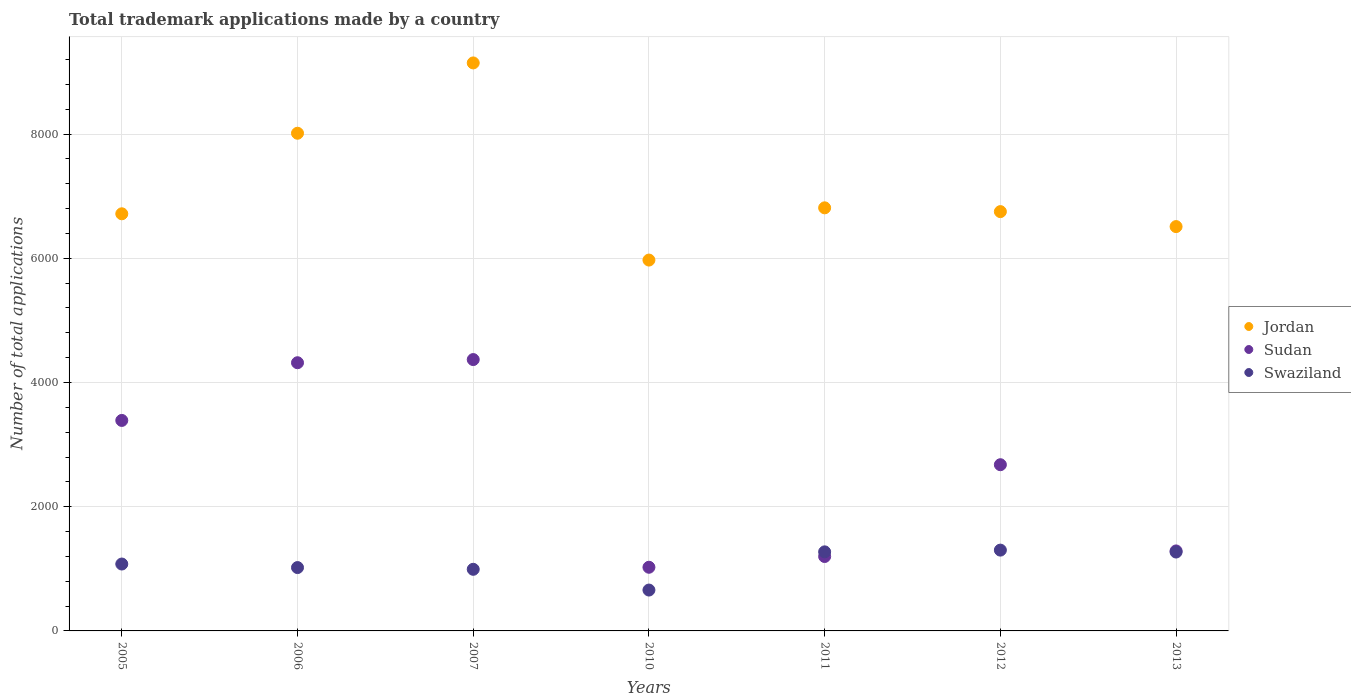Is the number of dotlines equal to the number of legend labels?
Provide a short and direct response. Yes. What is the number of applications made by in Jordan in 2013?
Your answer should be compact. 6510. Across all years, what is the maximum number of applications made by in Swaziland?
Your answer should be very brief. 1301. Across all years, what is the minimum number of applications made by in Swaziland?
Offer a very short reply. 658. What is the total number of applications made by in Jordan in the graph?
Your answer should be compact. 4.99e+04. What is the difference between the number of applications made by in Jordan in 2006 and that in 2010?
Make the answer very short. 2042. What is the difference between the number of applications made by in Sudan in 2006 and the number of applications made by in Jordan in 2012?
Your answer should be compact. -2433. What is the average number of applications made by in Sudan per year?
Offer a very short reply. 2609. In the year 2007, what is the difference between the number of applications made by in Jordan and number of applications made by in Swaziland?
Provide a short and direct response. 8153. In how many years, is the number of applications made by in Sudan greater than 5600?
Your answer should be compact. 0. What is the ratio of the number of applications made by in Jordan in 2011 to that in 2013?
Make the answer very short. 1.05. Is the difference between the number of applications made by in Jordan in 2010 and 2012 greater than the difference between the number of applications made by in Swaziland in 2010 and 2012?
Offer a very short reply. No. What is the difference between the highest and the second highest number of applications made by in Jordan?
Your response must be concise. 1132. What is the difference between the highest and the lowest number of applications made by in Sudan?
Give a very brief answer. 3344. In how many years, is the number of applications made by in Swaziland greater than the average number of applications made by in Swaziland taken over all years?
Your response must be concise. 3. Is the sum of the number of applications made by in Jordan in 2010 and 2012 greater than the maximum number of applications made by in Sudan across all years?
Give a very brief answer. Yes. Is it the case that in every year, the sum of the number of applications made by in Sudan and number of applications made by in Jordan  is greater than the number of applications made by in Swaziland?
Offer a terse response. Yes. Does the number of applications made by in Sudan monotonically increase over the years?
Your response must be concise. No. Is the number of applications made by in Swaziland strictly greater than the number of applications made by in Jordan over the years?
Provide a succinct answer. No. Is the number of applications made by in Jordan strictly less than the number of applications made by in Sudan over the years?
Your response must be concise. No. How many dotlines are there?
Provide a short and direct response. 3. How many years are there in the graph?
Your response must be concise. 7. Does the graph contain grids?
Your answer should be compact. Yes. Where does the legend appear in the graph?
Keep it short and to the point. Center right. How many legend labels are there?
Give a very brief answer. 3. How are the legend labels stacked?
Your answer should be compact. Vertical. What is the title of the graph?
Offer a very short reply. Total trademark applications made by a country. Does "Sudan" appear as one of the legend labels in the graph?
Keep it short and to the point. Yes. What is the label or title of the Y-axis?
Offer a terse response. Number of total applications. What is the Number of total applications of Jordan in 2005?
Your response must be concise. 6716. What is the Number of total applications in Sudan in 2005?
Make the answer very short. 3389. What is the Number of total applications in Swaziland in 2005?
Provide a short and direct response. 1077. What is the Number of total applications in Jordan in 2006?
Offer a very short reply. 8013. What is the Number of total applications of Sudan in 2006?
Keep it short and to the point. 4318. What is the Number of total applications of Swaziland in 2006?
Your response must be concise. 1020. What is the Number of total applications in Jordan in 2007?
Your answer should be very brief. 9145. What is the Number of total applications of Sudan in 2007?
Offer a terse response. 4369. What is the Number of total applications of Swaziland in 2007?
Your answer should be compact. 992. What is the Number of total applications of Jordan in 2010?
Provide a short and direct response. 5971. What is the Number of total applications of Sudan in 2010?
Make the answer very short. 1025. What is the Number of total applications of Swaziland in 2010?
Make the answer very short. 658. What is the Number of total applications in Jordan in 2011?
Keep it short and to the point. 6812. What is the Number of total applications of Sudan in 2011?
Your answer should be very brief. 1198. What is the Number of total applications of Swaziland in 2011?
Give a very brief answer. 1273. What is the Number of total applications in Jordan in 2012?
Offer a very short reply. 6751. What is the Number of total applications of Sudan in 2012?
Your response must be concise. 2676. What is the Number of total applications of Swaziland in 2012?
Your answer should be very brief. 1301. What is the Number of total applications of Jordan in 2013?
Ensure brevity in your answer.  6510. What is the Number of total applications of Sudan in 2013?
Make the answer very short. 1288. What is the Number of total applications in Swaziland in 2013?
Make the answer very short. 1270. Across all years, what is the maximum Number of total applications in Jordan?
Make the answer very short. 9145. Across all years, what is the maximum Number of total applications in Sudan?
Offer a terse response. 4369. Across all years, what is the maximum Number of total applications of Swaziland?
Provide a short and direct response. 1301. Across all years, what is the minimum Number of total applications in Jordan?
Your answer should be very brief. 5971. Across all years, what is the minimum Number of total applications in Sudan?
Your answer should be compact. 1025. Across all years, what is the minimum Number of total applications in Swaziland?
Provide a short and direct response. 658. What is the total Number of total applications in Jordan in the graph?
Ensure brevity in your answer.  4.99e+04. What is the total Number of total applications of Sudan in the graph?
Your answer should be very brief. 1.83e+04. What is the total Number of total applications in Swaziland in the graph?
Keep it short and to the point. 7591. What is the difference between the Number of total applications of Jordan in 2005 and that in 2006?
Provide a short and direct response. -1297. What is the difference between the Number of total applications in Sudan in 2005 and that in 2006?
Your response must be concise. -929. What is the difference between the Number of total applications of Swaziland in 2005 and that in 2006?
Ensure brevity in your answer.  57. What is the difference between the Number of total applications in Jordan in 2005 and that in 2007?
Your answer should be very brief. -2429. What is the difference between the Number of total applications in Sudan in 2005 and that in 2007?
Make the answer very short. -980. What is the difference between the Number of total applications in Jordan in 2005 and that in 2010?
Ensure brevity in your answer.  745. What is the difference between the Number of total applications of Sudan in 2005 and that in 2010?
Ensure brevity in your answer.  2364. What is the difference between the Number of total applications in Swaziland in 2005 and that in 2010?
Make the answer very short. 419. What is the difference between the Number of total applications of Jordan in 2005 and that in 2011?
Keep it short and to the point. -96. What is the difference between the Number of total applications in Sudan in 2005 and that in 2011?
Give a very brief answer. 2191. What is the difference between the Number of total applications in Swaziland in 2005 and that in 2011?
Make the answer very short. -196. What is the difference between the Number of total applications of Jordan in 2005 and that in 2012?
Your response must be concise. -35. What is the difference between the Number of total applications in Sudan in 2005 and that in 2012?
Make the answer very short. 713. What is the difference between the Number of total applications of Swaziland in 2005 and that in 2012?
Provide a succinct answer. -224. What is the difference between the Number of total applications in Jordan in 2005 and that in 2013?
Provide a short and direct response. 206. What is the difference between the Number of total applications of Sudan in 2005 and that in 2013?
Offer a terse response. 2101. What is the difference between the Number of total applications in Swaziland in 2005 and that in 2013?
Make the answer very short. -193. What is the difference between the Number of total applications of Jordan in 2006 and that in 2007?
Make the answer very short. -1132. What is the difference between the Number of total applications in Sudan in 2006 and that in 2007?
Give a very brief answer. -51. What is the difference between the Number of total applications of Jordan in 2006 and that in 2010?
Provide a succinct answer. 2042. What is the difference between the Number of total applications in Sudan in 2006 and that in 2010?
Your answer should be compact. 3293. What is the difference between the Number of total applications of Swaziland in 2006 and that in 2010?
Give a very brief answer. 362. What is the difference between the Number of total applications in Jordan in 2006 and that in 2011?
Offer a terse response. 1201. What is the difference between the Number of total applications of Sudan in 2006 and that in 2011?
Give a very brief answer. 3120. What is the difference between the Number of total applications of Swaziland in 2006 and that in 2011?
Keep it short and to the point. -253. What is the difference between the Number of total applications in Jordan in 2006 and that in 2012?
Provide a succinct answer. 1262. What is the difference between the Number of total applications in Sudan in 2006 and that in 2012?
Give a very brief answer. 1642. What is the difference between the Number of total applications of Swaziland in 2006 and that in 2012?
Make the answer very short. -281. What is the difference between the Number of total applications in Jordan in 2006 and that in 2013?
Your response must be concise. 1503. What is the difference between the Number of total applications of Sudan in 2006 and that in 2013?
Your response must be concise. 3030. What is the difference between the Number of total applications of Swaziland in 2006 and that in 2013?
Your response must be concise. -250. What is the difference between the Number of total applications in Jordan in 2007 and that in 2010?
Keep it short and to the point. 3174. What is the difference between the Number of total applications in Sudan in 2007 and that in 2010?
Give a very brief answer. 3344. What is the difference between the Number of total applications of Swaziland in 2007 and that in 2010?
Give a very brief answer. 334. What is the difference between the Number of total applications of Jordan in 2007 and that in 2011?
Your answer should be compact. 2333. What is the difference between the Number of total applications in Sudan in 2007 and that in 2011?
Your response must be concise. 3171. What is the difference between the Number of total applications in Swaziland in 2007 and that in 2011?
Your answer should be compact. -281. What is the difference between the Number of total applications in Jordan in 2007 and that in 2012?
Keep it short and to the point. 2394. What is the difference between the Number of total applications of Sudan in 2007 and that in 2012?
Provide a succinct answer. 1693. What is the difference between the Number of total applications of Swaziland in 2007 and that in 2012?
Offer a terse response. -309. What is the difference between the Number of total applications in Jordan in 2007 and that in 2013?
Ensure brevity in your answer.  2635. What is the difference between the Number of total applications in Sudan in 2007 and that in 2013?
Offer a terse response. 3081. What is the difference between the Number of total applications in Swaziland in 2007 and that in 2013?
Offer a terse response. -278. What is the difference between the Number of total applications of Jordan in 2010 and that in 2011?
Your response must be concise. -841. What is the difference between the Number of total applications of Sudan in 2010 and that in 2011?
Offer a very short reply. -173. What is the difference between the Number of total applications in Swaziland in 2010 and that in 2011?
Ensure brevity in your answer.  -615. What is the difference between the Number of total applications in Jordan in 2010 and that in 2012?
Your answer should be compact. -780. What is the difference between the Number of total applications in Sudan in 2010 and that in 2012?
Provide a short and direct response. -1651. What is the difference between the Number of total applications in Swaziland in 2010 and that in 2012?
Offer a very short reply. -643. What is the difference between the Number of total applications in Jordan in 2010 and that in 2013?
Offer a terse response. -539. What is the difference between the Number of total applications in Sudan in 2010 and that in 2013?
Provide a succinct answer. -263. What is the difference between the Number of total applications of Swaziland in 2010 and that in 2013?
Ensure brevity in your answer.  -612. What is the difference between the Number of total applications of Sudan in 2011 and that in 2012?
Provide a succinct answer. -1478. What is the difference between the Number of total applications of Swaziland in 2011 and that in 2012?
Give a very brief answer. -28. What is the difference between the Number of total applications in Jordan in 2011 and that in 2013?
Offer a terse response. 302. What is the difference between the Number of total applications of Sudan in 2011 and that in 2013?
Offer a terse response. -90. What is the difference between the Number of total applications in Swaziland in 2011 and that in 2013?
Your answer should be very brief. 3. What is the difference between the Number of total applications in Jordan in 2012 and that in 2013?
Offer a terse response. 241. What is the difference between the Number of total applications of Sudan in 2012 and that in 2013?
Give a very brief answer. 1388. What is the difference between the Number of total applications of Jordan in 2005 and the Number of total applications of Sudan in 2006?
Offer a terse response. 2398. What is the difference between the Number of total applications of Jordan in 2005 and the Number of total applications of Swaziland in 2006?
Offer a terse response. 5696. What is the difference between the Number of total applications in Sudan in 2005 and the Number of total applications in Swaziland in 2006?
Keep it short and to the point. 2369. What is the difference between the Number of total applications in Jordan in 2005 and the Number of total applications in Sudan in 2007?
Make the answer very short. 2347. What is the difference between the Number of total applications in Jordan in 2005 and the Number of total applications in Swaziland in 2007?
Your answer should be very brief. 5724. What is the difference between the Number of total applications of Sudan in 2005 and the Number of total applications of Swaziland in 2007?
Offer a very short reply. 2397. What is the difference between the Number of total applications in Jordan in 2005 and the Number of total applications in Sudan in 2010?
Your response must be concise. 5691. What is the difference between the Number of total applications in Jordan in 2005 and the Number of total applications in Swaziland in 2010?
Make the answer very short. 6058. What is the difference between the Number of total applications in Sudan in 2005 and the Number of total applications in Swaziland in 2010?
Keep it short and to the point. 2731. What is the difference between the Number of total applications in Jordan in 2005 and the Number of total applications in Sudan in 2011?
Keep it short and to the point. 5518. What is the difference between the Number of total applications of Jordan in 2005 and the Number of total applications of Swaziland in 2011?
Offer a very short reply. 5443. What is the difference between the Number of total applications of Sudan in 2005 and the Number of total applications of Swaziland in 2011?
Offer a terse response. 2116. What is the difference between the Number of total applications in Jordan in 2005 and the Number of total applications in Sudan in 2012?
Offer a very short reply. 4040. What is the difference between the Number of total applications of Jordan in 2005 and the Number of total applications of Swaziland in 2012?
Provide a short and direct response. 5415. What is the difference between the Number of total applications of Sudan in 2005 and the Number of total applications of Swaziland in 2012?
Provide a short and direct response. 2088. What is the difference between the Number of total applications of Jordan in 2005 and the Number of total applications of Sudan in 2013?
Provide a succinct answer. 5428. What is the difference between the Number of total applications in Jordan in 2005 and the Number of total applications in Swaziland in 2013?
Your response must be concise. 5446. What is the difference between the Number of total applications in Sudan in 2005 and the Number of total applications in Swaziland in 2013?
Ensure brevity in your answer.  2119. What is the difference between the Number of total applications in Jordan in 2006 and the Number of total applications in Sudan in 2007?
Keep it short and to the point. 3644. What is the difference between the Number of total applications in Jordan in 2006 and the Number of total applications in Swaziland in 2007?
Make the answer very short. 7021. What is the difference between the Number of total applications of Sudan in 2006 and the Number of total applications of Swaziland in 2007?
Your response must be concise. 3326. What is the difference between the Number of total applications of Jordan in 2006 and the Number of total applications of Sudan in 2010?
Make the answer very short. 6988. What is the difference between the Number of total applications in Jordan in 2006 and the Number of total applications in Swaziland in 2010?
Ensure brevity in your answer.  7355. What is the difference between the Number of total applications of Sudan in 2006 and the Number of total applications of Swaziland in 2010?
Offer a very short reply. 3660. What is the difference between the Number of total applications in Jordan in 2006 and the Number of total applications in Sudan in 2011?
Your answer should be very brief. 6815. What is the difference between the Number of total applications in Jordan in 2006 and the Number of total applications in Swaziland in 2011?
Provide a succinct answer. 6740. What is the difference between the Number of total applications in Sudan in 2006 and the Number of total applications in Swaziland in 2011?
Your response must be concise. 3045. What is the difference between the Number of total applications in Jordan in 2006 and the Number of total applications in Sudan in 2012?
Provide a succinct answer. 5337. What is the difference between the Number of total applications of Jordan in 2006 and the Number of total applications of Swaziland in 2012?
Ensure brevity in your answer.  6712. What is the difference between the Number of total applications in Sudan in 2006 and the Number of total applications in Swaziland in 2012?
Provide a short and direct response. 3017. What is the difference between the Number of total applications of Jordan in 2006 and the Number of total applications of Sudan in 2013?
Ensure brevity in your answer.  6725. What is the difference between the Number of total applications of Jordan in 2006 and the Number of total applications of Swaziland in 2013?
Make the answer very short. 6743. What is the difference between the Number of total applications in Sudan in 2006 and the Number of total applications in Swaziland in 2013?
Offer a terse response. 3048. What is the difference between the Number of total applications of Jordan in 2007 and the Number of total applications of Sudan in 2010?
Give a very brief answer. 8120. What is the difference between the Number of total applications of Jordan in 2007 and the Number of total applications of Swaziland in 2010?
Give a very brief answer. 8487. What is the difference between the Number of total applications in Sudan in 2007 and the Number of total applications in Swaziland in 2010?
Provide a short and direct response. 3711. What is the difference between the Number of total applications in Jordan in 2007 and the Number of total applications in Sudan in 2011?
Make the answer very short. 7947. What is the difference between the Number of total applications in Jordan in 2007 and the Number of total applications in Swaziland in 2011?
Offer a terse response. 7872. What is the difference between the Number of total applications of Sudan in 2007 and the Number of total applications of Swaziland in 2011?
Give a very brief answer. 3096. What is the difference between the Number of total applications in Jordan in 2007 and the Number of total applications in Sudan in 2012?
Your answer should be very brief. 6469. What is the difference between the Number of total applications of Jordan in 2007 and the Number of total applications of Swaziland in 2012?
Offer a terse response. 7844. What is the difference between the Number of total applications of Sudan in 2007 and the Number of total applications of Swaziland in 2012?
Offer a very short reply. 3068. What is the difference between the Number of total applications in Jordan in 2007 and the Number of total applications in Sudan in 2013?
Your answer should be compact. 7857. What is the difference between the Number of total applications in Jordan in 2007 and the Number of total applications in Swaziland in 2013?
Ensure brevity in your answer.  7875. What is the difference between the Number of total applications in Sudan in 2007 and the Number of total applications in Swaziland in 2013?
Give a very brief answer. 3099. What is the difference between the Number of total applications in Jordan in 2010 and the Number of total applications in Sudan in 2011?
Give a very brief answer. 4773. What is the difference between the Number of total applications in Jordan in 2010 and the Number of total applications in Swaziland in 2011?
Keep it short and to the point. 4698. What is the difference between the Number of total applications of Sudan in 2010 and the Number of total applications of Swaziland in 2011?
Provide a succinct answer. -248. What is the difference between the Number of total applications of Jordan in 2010 and the Number of total applications of Sudan in 2012?
Your answer should be compact. 3295. What is the difference between the Number of total applications of Jordan in 2010 and the Number of total applications of Swaziland in 2012?
Give a very brief answer. 4670. What is the difference between the Number of total applications in Sudan in 2010 and the Number of total applications in Swaziland in 2012?
Ensure brevity in your answer.  -276. What is the difference between the Number of total applications in Jordan in 2010 and the Number of total applications in Sudan in 2013?
Provide a short and direct response. 4683. What is the difference between the Number of total applications in Jordan in 2010 and the Number of total applications in Swaziland in 2013?
Your response must be concise. 4701. What is the difference between the Number of total applications in Sudan in 2010 and the Number of total applications in Swaziland in 2013?
Your answer should be compact. -245. What is the difference between the Number of total applications of Jordan in 2011 and the Number of total applications of Sudan in 2012?
Your answer should be compact. 4136. What is the difference between the Number of total applications in Jordan in 2011 and the Number of total applications in Swaziland in 2012?
Provide a succinct answer. 5511. What is the difference between the Number of total applications in Sudan in 2011 and the Number of total applications in Swaziland in 2012?
Offer a terse response. -103. What is the difference between the Number of total applications in Jordan in 2011 and the Number of total applications in Sudan in 2013?
Ensure brevity in your answer.  5524. What is the difference between the Number of total applications of Jordan in 2011 and the Number of total applications of Swaziland in 2013?
Keep it short and to the point. 5542. What is the difference between the Number of total applications in Sudan in 2011 and the Number of total applications in Swaziland in 2013?
Provide a succinct answer. -72. What is the difference between the Number of total applications of Jordan in 2012 and the Number of total applications of Sudan in 2013?
Your answer should be compact. 5463. What is the difference between the Number of total applications of Jordan in 2012 and the Number of total applications of Swaziland in 2013?
Provide a short and direct response. 5481. What is the difference between the Number of total applications in Sudan in 2012 and the Number of total applications in Swaziland in 2013?
Make the answer very short. 1406. What is the average Number of total applications of Jordan per year?
Provide a short and direct response. 7131.14. What is the average Number of total applications in Sudan per year?
Your response must be concise. 2609. What is the average Number of total applications of Swaziland per year?
Offer a very short reply. 1084.43. In the year 2005, what is the difference between the Number of total applications of Jordan and Number of total applications of Sudan?
Offer a terse response. 3327. In the year 2005, what is the difference between the Number of total applications of Jordan and Number of total applications of Swaziland?
Make the answer very short. 5639. In the year 2005, what is the difference between the Number of total applications in Sudan and Number of total applications in Swaziland?
Provide a succinct answer. 2312. In the year 2006, what is the difference between the Number of total applications of Jordan and Number of total applications of Sudan?
Keep it short and to the point. 3695. In the year 2006, what is the difference between the Number of total applications of Jordan and Number of total applications of Swaziland?
Provide a short and direct response. 6993. In the year 2006, what is the difference between the Number of total applications of Sudan and Number of total applications of Swaziland?
Provide a short and direct response. 3298. In the year 2007, what is the difference between the Number of total applications of Jordan and Number of total applications of Sudan?
Your response must be concise. 4776. In the year 2007, what is the difference between the Number of total applications of Jordan and Number of total applications of Swaziland?
Provide a succinct answer. 8153. In the year 2007, what is the difference between the Number of total applications of Sudan and Number of total applications of Swaziland?
Keep it short and to the point. 3377. In the year 2010, what is the difference between the Number of total applications of Jordan and Number of total applications of Sudan?
Your answer should be compact. 4946. In the year 2010, what is the difference between the Number of total applications of Jordan and Number of total applications of Swaziland?
Keep it short and to the point. 5313. In the year 2010, what is the difference between the Number of total applications of Sudan and Number of total applications of Swaziland?
Provide a short and direct response. 367. In the year 2011, what is the difference between the Number of total applications of Jordan and Number of total applications of Sudan?
Offer a very short reply. 5614. In the year 2011, what is the difference between the Number of total applications in Jordan and Number of total applications in Swaziland?
Provide a succinct answer. 5539. In the year 2011, what is the difference between the Number of total applications of Sudan and Number of total applications of Swaziland?
Provide a short and direct response. -75. In the year 2012, what is the difference between the Number of total applications of Jordan and Number of total applications of Sudan?
Give a very brief answer. 4075. In the year 2012, what is the difference between the Number of total applications in Jordan and Number of total applications in Swaziland?
Ensure brevity in your answer.  5450. In the year 2012, what is the difference between the Number of total applications in Sudan and Number of total applications in Swaziland?
Ensure brevity in your answer.  1375. In the year 2013, what is the difference between the Number of total applications in Jordan and Number of total applications in Sudan?
Offer a terse response. 5222. In the year 2013, what is the difference between the Number of total applications in Jordan and Number of total applications in Swaziland?
Your response must be concise. 5240. What is the ratio of the Number of total applications of Jordan in 2005 to that in 2006?
Offer a terse response. 0.84. What is the ratio of the Number of total applications in Sudan in 2005 to that in 2006?
Your response must be concise. 0.78. What is the ratio of the Number of total applications in Swaziland in 2005 to that in 2006?
Offer a very short reply. 1.06. What is the ratio of the Number of total applications in Jordan in 2005 to that in 2007?
Your answer should be very brief. 0.73. What is the ratio of the Number of total applications of Sudan in 2005 to that in 2007?
Provide a short and direct response. 0.78. What is the ratio of the Number of total applications in Swaziland in 2005 to that in 2007?
Keep it short and to the point. 1.09. What is the ratio of the Number of total applications of Jordan in 2005 to that in 2010?
Provide a short and direct response. 1.12. What is the ratio of the Number of total applications of Sudan in 2005 to that in 2010?
Your answer should be compact. 3.31. What is the ratio of the Number of total applications in Swaziland in 2005 to that in 2010?
Ensure brevity in your answer.  1.64. What is the ratio of the Number of total applications of Jordan in 2005 to that in 2011?
Your answer should be compact. 0.99. What is the ratio of the Number of total applications of Sudan in 2005 to that in 2011?
Provide a succinct answer. 2.83. What is the ratio of the Number of total applications of Swaziland in 2005 to that in 2011?
Provide a short and direct response. 0.85. What is the ratio of the Number of total applications in Sudan in 2005 to that in 2012?
Your response must be concise. 1.27. What is the ratio of the Number of total applications in Swaziland in 2005 to that in 2012?
Your answer should be compact. 0.83. What is the ratio of the Number of total applications in Jordan in 2005 to that in 2013?
Make the answer very short. 1.03. What is the ratio of the Number of total applications in Sudan in 2005 to that in 2013?
Offer a terse response. 2.63. What is the ratio of the Number of total applications in Swaziland in 2005 to that in 2013?
Make the answer very short. 0.85. What is the ratio of the Number of total applications in Jordan in 2006 to that in 2007?
Ensure brevity in your answer.  0.88. What is the ratio of the Number of total applications in Sudan in 2006 to that in 2007?
Your answer should be compact. 0.99. What is the ratio of the Number of total applications in Swaziland in 2006 to that in 2007?
Your answer should be very brief. 1.03. What is the ratio of the Number of total applications in Jordan in 2006 to that in 2010?
Make the answer very short. 1.34. What is the ratio of the Number of total applications in Sudan in 2006 to that in 2010?
Ensure brevity in your answer.  4.21. What is the ratio of the Number of total applications in Swaziland in 2006 to that in 2010?
Provide a succinct answer. 1.55. What is the ratio of the Number of total applications of Jordan in 2006 to that in 2011?
Your answer should be very brief. 1.18. What is the ratio of the Number of total applications of Sudan in 2006 to that in 2011?
Offer a very short reply. 3.6. What is the ratio of the Number of total applications of Swaziland in 2006 to that in 2011?
Your answer should be compact. 0.8. What is the ratio of the Number of total applications in Jordan in 2006 to that in 2012?
Your answer should be compact. 1.19. What is the ratio of the Number of total applications in Sudan in 2006 to that in 2012?
Your response must be concise. 1.61. What is the ratio of the Number of total applications of Swaziland in 2006 to that in 2012?
Ensure brevity in your answer.  0.78. What is the ratio of the Number of total applications in Jordan in 2006 to that in 2013?
Offer a terse response. 1.23. What is the ratio of the Number of total applications of Sudan in 2006 to that in 2013?
Give a very brief answer. 3.35. What is the ratio of the Number of total applications of Swaziland in 2006 to that in 2013?
Your answer should be very brief. 0.8. What is the ratio of the Number of total applications of Jordan in 2007 to that in 2010?
Give a very brief answer. 1.53. What is the ratio of the Number of total applications in Sudan in 2007 to that in 2010?
Offer a very short reply. 4.26. What is the ratio of the Number of total applications of Swaziland in 2007 to that in 2010?
Ensure brevity in your answer.  1.51. What is the ratio of the Number of total applications of Jordan in 2007 to that in 2011?
Make the answer very short. 1.34. What is the ratio of the Number of total applications in Sudan in 2007 to that in 2011?
Give a very brief answer. 3.65. What is the ratio of the Number of total applications in Swaziland in 2007 to that in 2011?
Give a very brief answer. 0.78. What is the ratio of the Number of total applications of Jordan in 2007 to that in 2012?
Provide a short and direct response. 1.35. What is the ratio of the Number of total applications in Sudan in 2007 to that in 2012?
Ensure brevity in your answer.  1.63. What is the ratio of the Number of total applications in Swaziland in 2007 to that in 2012?
Your answer should be compact. 0.76. What is the ratio of the Number of total applications in Jordan in 2007 to that in 2013?
Provide a succinct answer. 1.4. What is the ratio of the Number of total applications of Sudan in 2007 to that in 2013?
Give a very brief answer. 3.39. What is the ratio of the Number of total applications in Swaziland in 2007 to that in 2013?
Your answer should be very brief. 0.78. What is the ratio of the Number of total applications of Jordan in 2010 to that in 2011?
Make the answer very short. 0.88. What is the ratio of the Number of total applications of Sudan in 2010 to that in 2011?
Give a very brief answer. 0.86. What is the ratio of the Number of total applications of Swaziland in 2010 to that in 2011?
Give a very brief answer. 0.52. What is the ratio of the Number of total applications in Jordan in 2010 to that in 2012?
Ensure brevity in your answer.  0.88. What is the ratio of the Number of total applications in Sudan in 2010 to that in 2012?
Give a very brief answer. 0.38. What is the ratio of the Number of total applications in Swaziland in 2010 to that in 2012?
Your response must be concise. 0.51. What is the ratio of the Number of total applications in Jordan in 2010 to that in 2013?
Make the answer very short. 0.92. What is the ratio of the Number of total applications in Sudan in 2010 to that in 2013?
Offer a very short reply. 0.8. What is the ratio of the Number of total applications of Swaziland in 2010 to that in 2013?
Provide a succinct answer. 0.52. What is the ratio of the Number of total applications in Sudan in 2011 to that in 2012?
Your answer should be compact. 0.45. What is the ratio of the Number of total applications in Swaziland in 2011 to that in 2012?
Give a very brief answer. 0.98. What is the ratio of the Number of total applications of Jordan in 2011 to that in 2013?
Provide a succinct answer. 1.05. What is the ratio of the Number of total applications in Sudan in 2011 to that in 2013?
Keep it short and to the point. 0.93. What is the ratio of the Number of total applications of Swaziland in 2011 to that in 2013?
Provide a succinct answer. 1. What is the ratio of the Number of total applications of Sudan in 2012 to that in 2013?
Keep it short and to the point. 2.08. What is the ratio of the Number of total applications of Swaziland in 2012 to that in 2013?
Offer a very short reply. 1.02. What is the difference between the highest and the second highest Number of total applications of Jordan?
Provide a succinct answer. 1132. What is the difference between the highest and the lowest Number of total applications in Jordan?
Offer a terse response. 3174. What is the difference between the highest and the lowest Number of total applications of Sudan?
Keep it short and to the point. 3344. What is the difference between the highest and the lowest Number of total applications in Swaziland?
Your answer should be very brief. 643. 